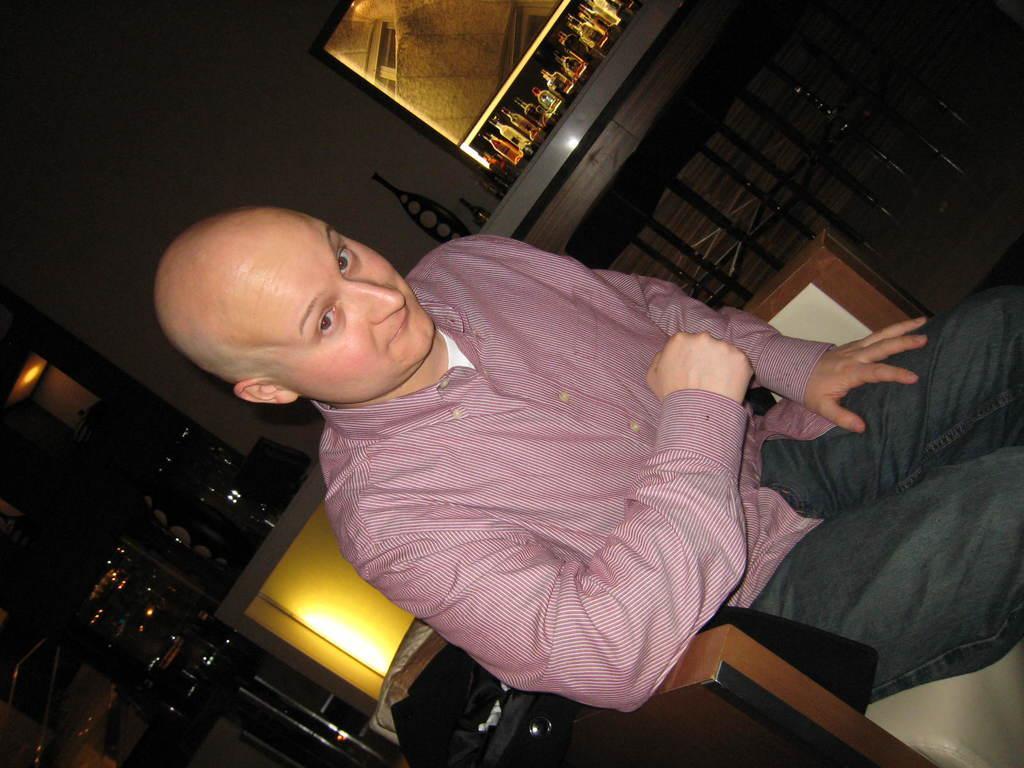Please provide a concise description of this image. In this picture, we see a man is sitting on the chair. Behind him, we see a wall in white and yellow color. Beside him, we see the stools. On the left side, we see a rack in which white plates are placed. At the top, we see a rack in which the glass bottles and the alcohol bottles are placed. In the background, we see a wall in white color. This picture might be clicked in the dark. 